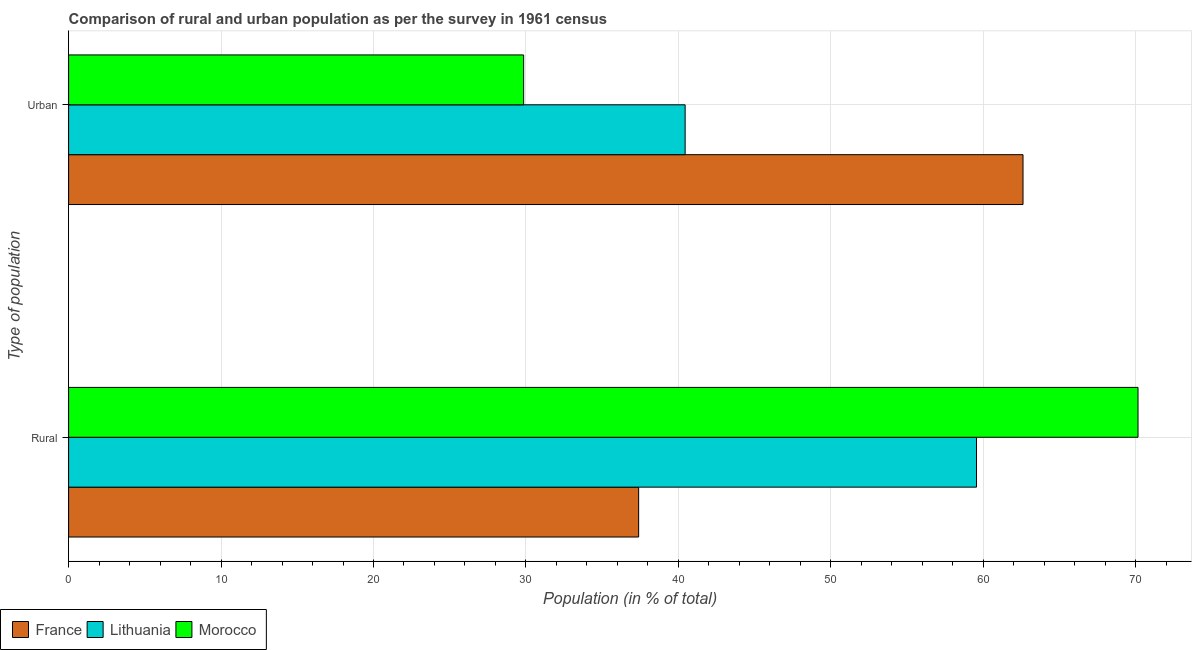How many different coloured bars are there?
Make the answer very short. 3. Are the number of bars per tick equal to the number of legend labels?
Your response must be concise. Yes. Are the number of bars on each tick of the Y-axis equal?
Make the answer very short. Yes. How many bars are there on the 1st tick from the bottom?
Offer a very short reply. 3. What is the label of the 1st group of bars from the top?
Give a very brief answer. Urban. What is the urban population in Morocco?
Provide a short and direct response. 29.85. Across all countries, what is the maximum rural population?
Give a very brief answer. 70.15. Across all countries, what is the minimum rural population?
Your answer should be very brief. 37.39. In which country was the urban population maximum?
Your response must be concise. France. In which country was the urban population minimum?
Provide a short and direct response. Morocco. What is the total rural population in the graph?
Keep it short and to the point. 167.1. What is the difference between the urban population in France and that in Morocco?
Your answer should be compact. 32.76. What is the difference between the urban population in Lithuania and the rural population in Morocco?
Offer a terse response. -29.71. What is the average urban population per country?
Keep it short and to the point. 44.3. What is the difference between the rural population and urban population in France?
Your answer should be compact. -25.21. What is the ratio of the urban population in Morocco to that in Lithuania?
Offer a very short reply. 0.74. In how many countries, is the urban population greater than the average urban population taken over all countries?
Your answer should be very brief. 1. What does the 3rd bar from the top in Rural represents?
Give a very brief answer. France. What does the 3rd bar from the bottom in Rural represents?
Provide a short and direct response. Morocco. What is the difference between two consecutive major ticks on the X-axis?
Your answer should be very brief. 10. Are the values on the major ticks of X-axis written in scientific E-notation?
Provide a succinct answer. No. Does the graph contain any zero values?
Provide a short and direct response. No. Where does the legend appear in the graph?
Your response must be concise. Bottom left. How many legend labels are there?
Provide a short and direct response. 3. How are the legend labels stacked?
Your response must be concise. Horizontal. What is the title of the graph?
Make the answer very short. Comparison of rural and urban population as per the survey in 1961 census. What is the label or title of the X-axis?
Ensure brevity in your answer.  Population (in % of total). What is the label or title of the Y-axis?
Your response must be concise. Type of population. What is the Population (in % of total) of France in Rural?
Your response must be concise. 37.39. What is the Population (in % of total) of Lithuania in Rural?
Give a very brief answer. 59.56. What is the Population (in % of total) of Morocco in Rural?
Your answer should be very brief. 70.15. What is the Population (in % of total) of France in Urban?
Give a very brief answer. 62.61. What is the Population (in % of total) in Lithuania in Urban?
Provide a short and direct response. 40.44. What is the Population (in % of total) of Morocco in Urban?
Provide a succinct answer. 29.85. Across all Type of population, what is the maximum Population (in % of total) of France?
Offer a terse response. 62.61. Across all Type of population, what is the maximum Population (in % of total) of Lithuania?
Ensure brevity in your answer.  59.56. Across all Type of population, what is the maximum Population (in % of total) in Morocco?
Your response must be concise. 70.15. Across all Type of population, what is the minimum Population (in % of total) of France?
Your answer should be very brief. 37.39. Across all Type of population, what is the minimum Population (in % of total) of Lithuania?
Offer a terse response. 40.44. Across all Type of population, what is the minimum Population (in % of total) in Morocco?
Offer a very short reply. 29.85. What is the total Population (in % of total) of Morocco in the graph?
Ensure brevity in your answer.  100. What is the difference between the Population (in % of total) in France in Rural and that in Urban?
Ensure brevity in your answer.  -25.21. What is the difference between the Population (in % of total) in Lithuania in Rural and that in Urban?
Your answer should be compact. 19.11. What is the difference between the Population (in % of total) of Morocco in Rural and that in Urban?
Your answer should be compact. 40.3. What is the difference between the Population (in % of total) in France in Rural and the Population (in % of total) in Lithuania in Urban?
Give a very brief answer. -3.05. What is the difference between the Population (in % of total) in France in Rural and the Population (in % of total) in Morocco in Urban?
Ensure brevity in your answer.  7.54. What is the difference between the Population (in % of total) in Lithuania in Rural and the Population (in % of total) in Morocco in Urban?
Ensure brevity in your answer.  29.71. What is the average Population (in % of total) in France per Type of population?
Give a very brief answer. 50. What is the average Population (in % of total) in Morocco per Type of population?
Your answer should be compact. 50. What is the difference between the Population (in % of total) in France and Population (in % of total) in Lithuania in Rural?
Your response must be concise. -22.16. What is the difference between the Population (in % of total) in France and Population (in % of total) in Morocco in Rural?
Ensure brevity in your answer.  -32.76. What is the difference between the Population (in % of total) in Lithuania and Population (in % of total) in Morocco in Rural?
Your answer should be compact. -10.59. What is the difference between the Population (in % of total) of France and Population (in % of total) of Lithuania in Urban?
Provide a succinct answer. 22.16. What is the difference between the Population (in % of total) of France and Population (in % of total) of Morocco in Urban?
Your response must be concise. 32.76. What is the difference between the Population (in % of total) of Lithuania and Population (in % of total) of Morocco in Urban?
Make the answer very short. 10.59. What is the ratio of the Population (in % of total) in France in Rural to that in Urban?
Offer a terse response. 0.6. What is the ratio of the Population (in % of total) in Lithuania in Rural to that in Urban?
Keep it short and to the point. 1.47. What is the ratio of the Population (in % of total) in Morocco in Rural to that in Urban?
Offer a very short reply. 2.35. What is the difference between the highest and the second highest Population (in % of total) of France?
Ensure brevity in your answer.  25.21. What is the difference between the highest and the second highest Population (in % of total) of Lithuania?
Your response must be concise. 19.11. What is the difference between the highest and the second highest Population (in % of total) in Morocco?
Your response must be concise. 40.3. What is the difference between the highest and the lowest Population (in % of total) in France?
Your answer should be very brief. 25.21. What is the difference between the highest and the lowest Population (in % of total) in Lithuania?
Your response must be concise. 19.11. What is the difference between the highest and the lowest Population (in % of total) in Morocco?
Your response must be concise. 40.3. 